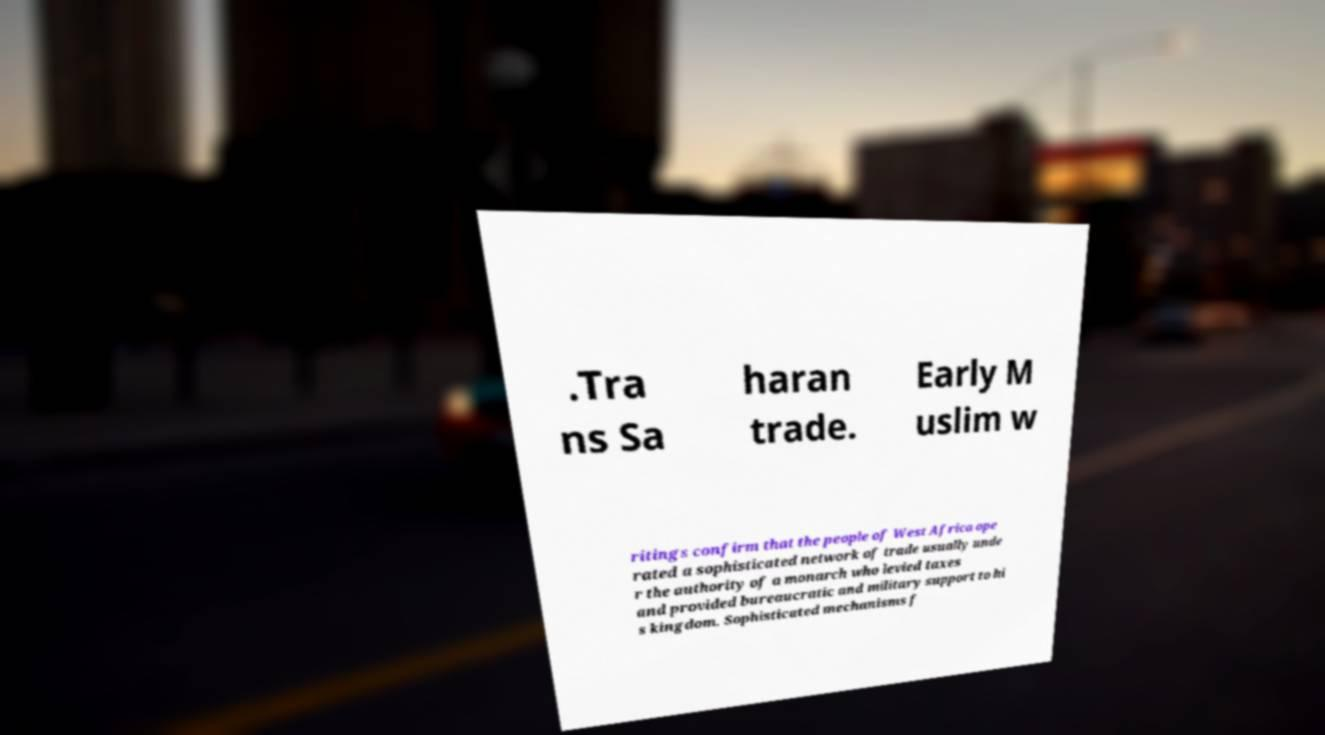For documentation purposes, I need the text within this image transcribed. Could you provide that? .Tra ns Sa haran trade. Early M uslim w ritings confirm that the people of West Africa ope rated a sophisticated network of trade usually unde r the authority of a monarch who levied taxes and provided bureaucratic and military support to hi s kingdom. Sophisticated mechanisms f 